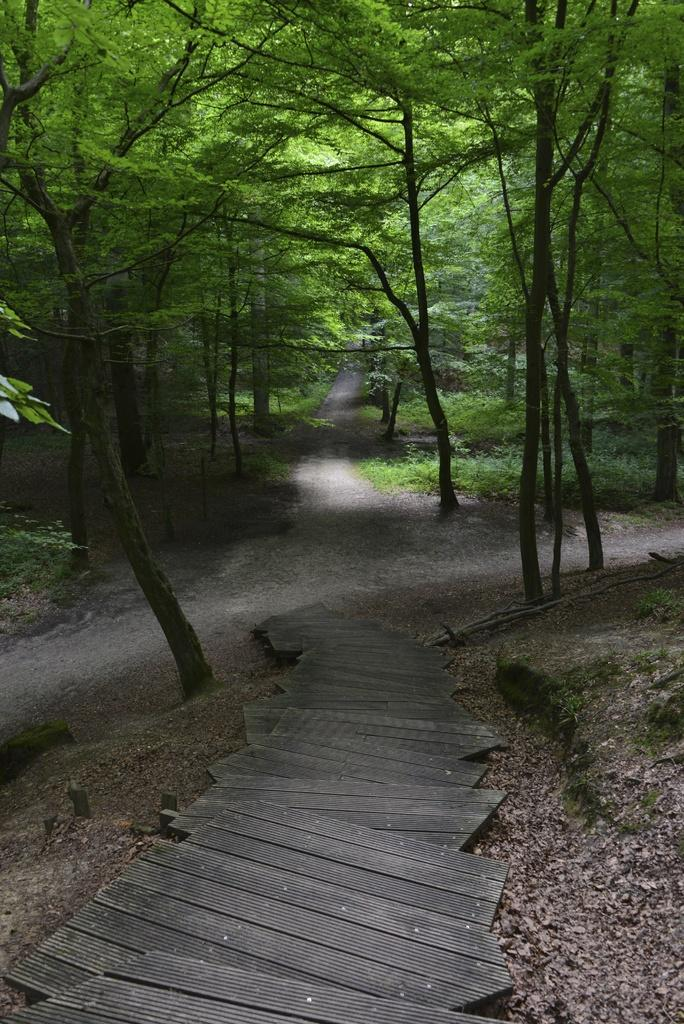What type of material is used for the planks in the image? The wooden planks in the image are made of wood. What can be seen running through the image? There is a road in the image. What type of vegetation is present in the image? There are plants in the image. What is covering the ground in the image? Dried leaves are present on the ground in the image. What can be seen in the distance in the image? There are trees visible in the background of the image. How much debt is represented by the wooden planks in the image? There is no debt represented by the wooden planks in the image; they are simply wooden planks. Can you see a baseball game happening in the image? There is no baseball game present in the image. 